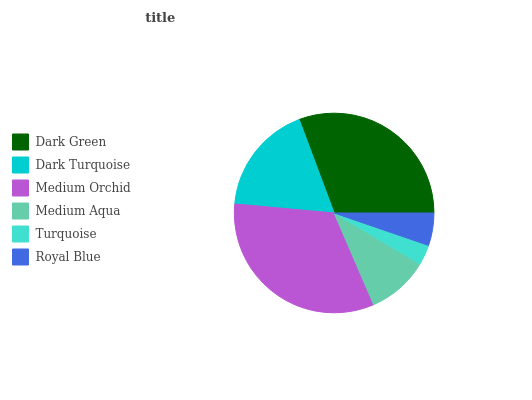Is Turquoise the minimum?
Answer yes or no. Yes. Is Medium Orchid the maximum?
Answer yes or no. Yes. Is Dark Turquoise the minimum?
Answer yes or no. No. Is Dark Turquoise the maximum?
Answer yes or no. No. Is Dark Green greater than Dark Turquoise?
Answer yes or no. Yes. Is Dark Turquoise less than Dark Green?
Answer yes or no. Yes. Is Dark Turquoise greater than Dark Green?
Answer yes or no. No. Is Dark Green less than Dark Turquoise?
Answer yes or no. No. Is Dark Turquoise the high median?
Answer yes or no. Yes. Is Medium Aqua the low median?
Answer yes or no. Yes. Is Turquoise the high median?
Answer yes or no. No. Is Dark Turquoise the low median?
Answer yes or no. No. 